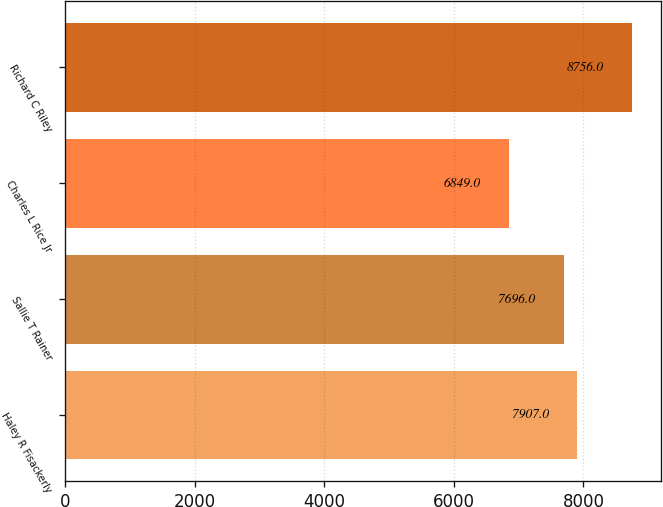Convert chart. <chart><loc_0><loc_0><loc_500><loc_500><bar_chart><fcel>Haley R Fisackerly<fcel>Sallie T Rainer<fcel>Charles L Rice Jr<fcel>Richard C Riley<nl><fcel>7907<fcel>7696<fcel>6849<fcel>8756<nl></chart> 